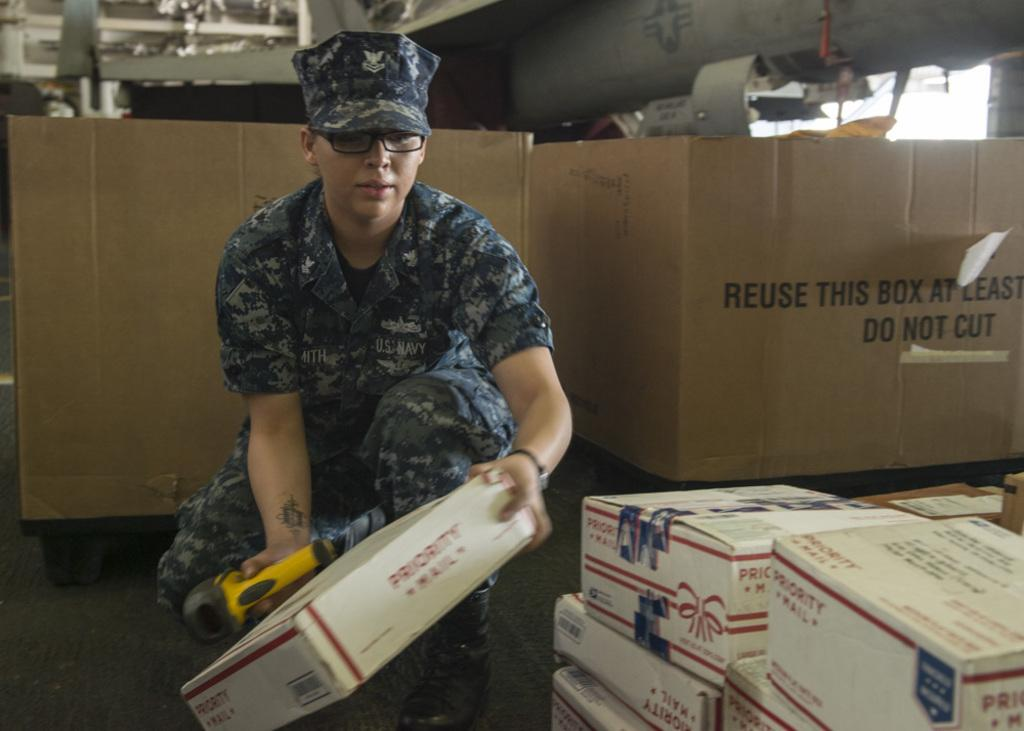<image>
Give a short and clear explanation of the subsequent image. A person holding onto a priority mail box 